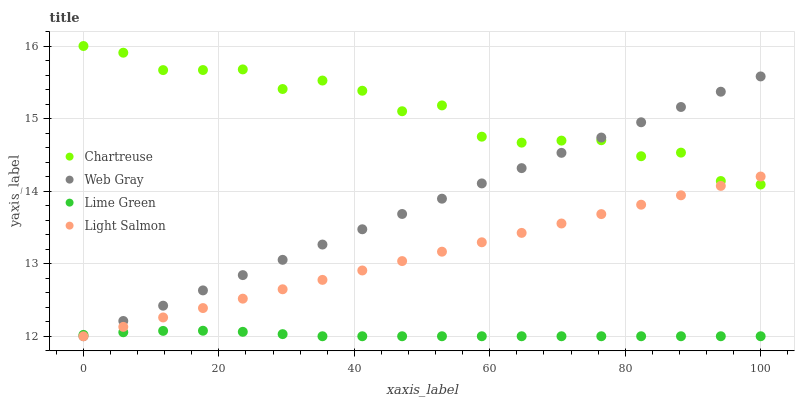Does Lime Green have the minimum area under the curve?
Answer yes or no. Yes. Does Chartreuse have the maximum area under the curve?
Answer yes or no. Yes. Does Web Gray have the minimum area under the curve?
Answer yes or no. No. Does Web Gray have the maximum area under the curve?
Answer yes or no. No. Is Light Salmon the smoothest?
Answer yes or no. Yes. Is Chartreuse the roughest?
Answer yes or no. Yes. Is Web Gray the smoothest?
Answer yes or no. No. Is Web Gray the roughest?
Answer yes or no. No. Does Web Gray have the lowest value?
Answer yes or no. Yes. Does Chartreuse have the highest value?
Answer yes or no. Yes. Does Web Gray have the highest value?
Answer yes or no. No. Is Lime Green less than Chartreuse?
Answer yes or no. Yes. Is Chartreuse greater than Lime Green?
Answer yes or no. Yes. Does Light Salmon intersect Lime Green?
Answer yes or no. Yes. Is Light Salmon less than Lime Green?
Answer yes or no. No. Is Light Salmon greater than Lime Green?
Answer yes or no. No. Does Lime Green intersect Chartreuse?
Answer yes or no. No. 